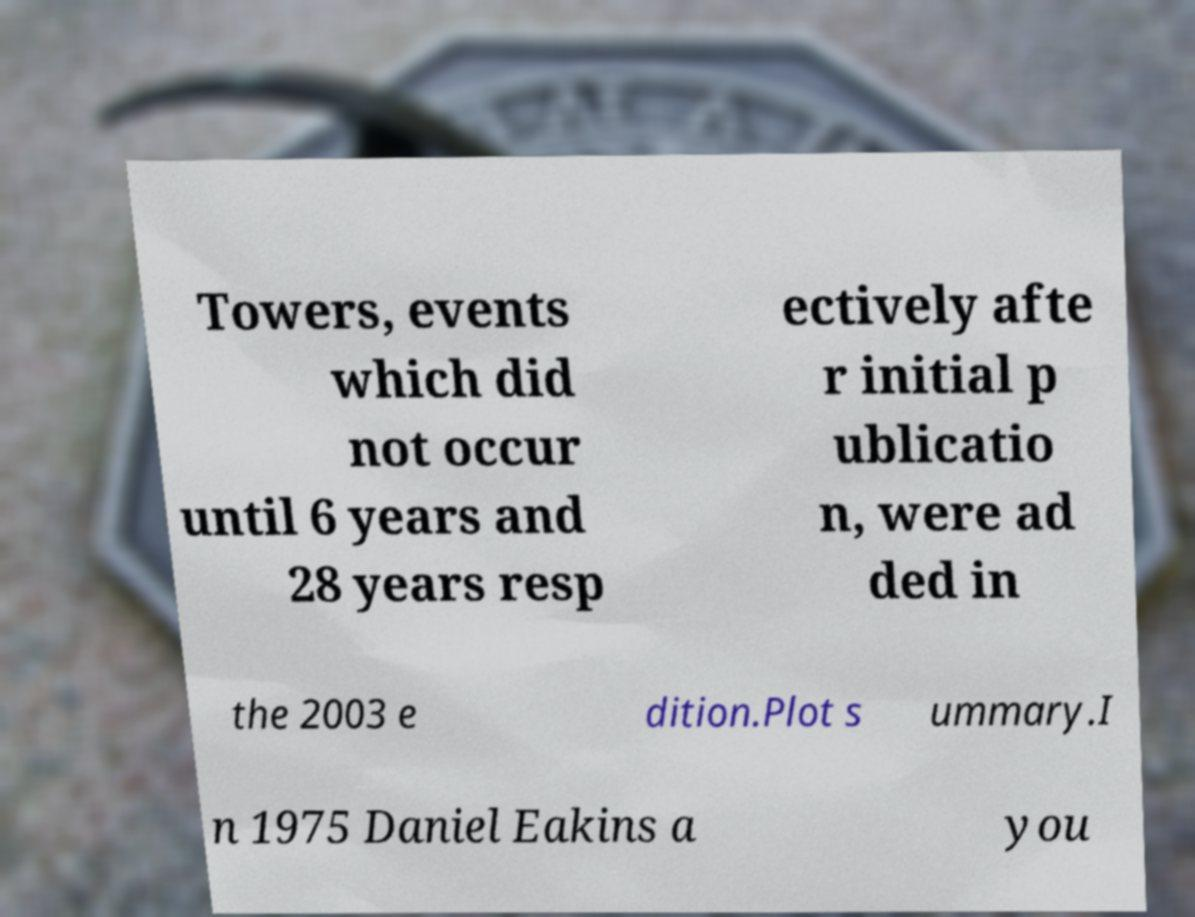Could you extract and type out the text from this image? Towers, events which did not occur until 6 years and 28 years resp ectively afte r initial p ublicatio n, were ad ded in the 2003 e dition.Plot s ummary.I n 1975 Daniel Eakins a you 